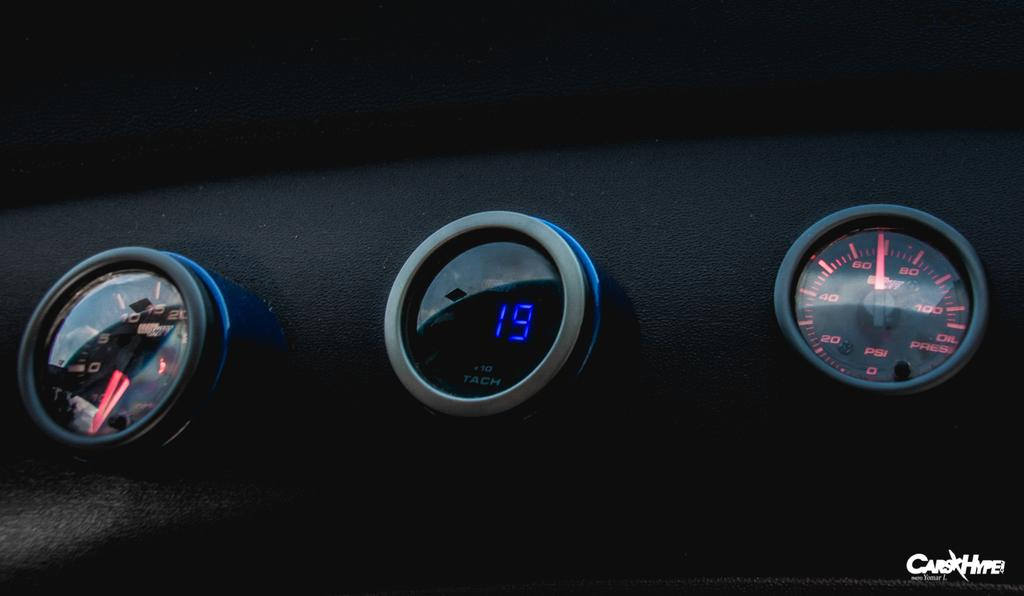What objects are present in the image? There are three meters in the image. How are the meters positioned in relation to each other? The meters are arranged in a row. What type of glue is being used to hold the meters together in the image? There is no glue present in the image, and the meters are not attached to each other. 